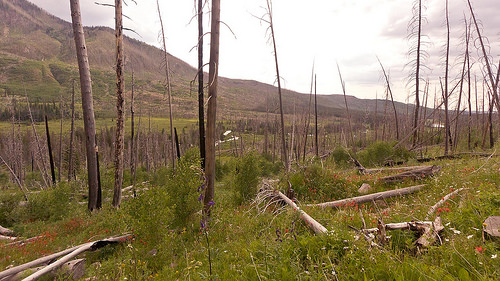<image>
Is there a tree in front of the grass? No. The tree is not in front of the grass. The spatial positioning shows a different relationship between these objects. 